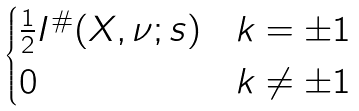<formula> <loc_0><loc_0><loc_500><loc_500>\begin{cases} \frac { 1 } { 2 } I ^ { \# } ( X , \nu ; s ) & k = \pm 1 \\ 0 & k \neq \pm 1 \end{cases}</formula> 